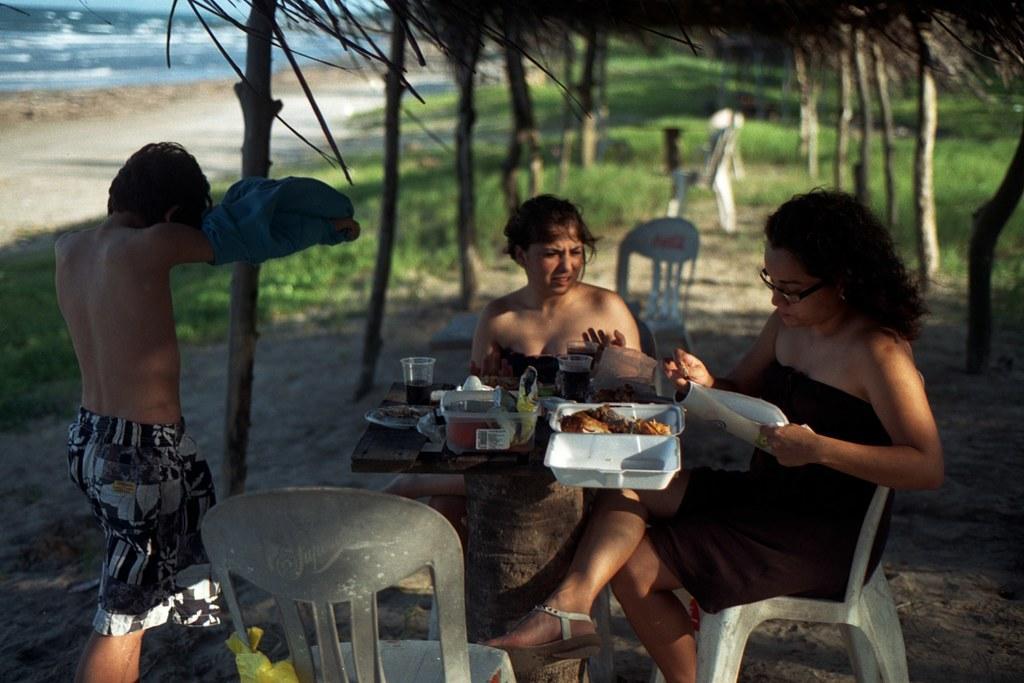In one or two sentences, can you explain what this image depicts? In the foreground there are three persons. Out of which two women´s are sitting on the chair, in front of the table on which glass, plates, tray, box and food items are kept. And one person is standing. In the background two person standing. In the left top, there is a ocean. Next to that there is a beach. On the top there is a bamboo hut. In the middle of the image, a grass is visible. This image is taken during day time in a sunny day. 